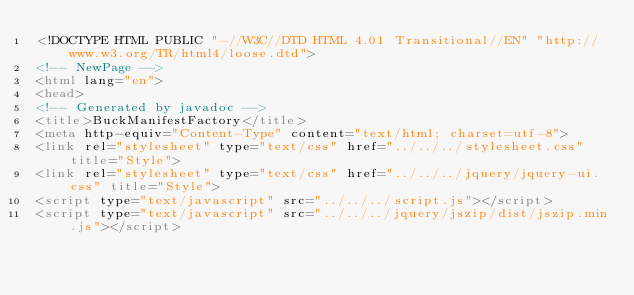Convert code to text. <code><loc_0><loc_0><loc_500><loc_500><_HTML_><!DOCTYPE HTML PUBLIC "-//W3C//DTD HTML 4.01 Transitional//EN" "http://www.w3.org/TR/html4/loose.dtd">
<!-- NewPage -->
<html lang="en">
<head>
<!-- Generated by javadoc -->
<title>BuckManifestFactory</title>
<meta http-equiv="Content-Type" content="text/html; charset=utf-8">
<link rel="stylesheet" type="text/css" href="../../../stylesheet.css" title="Style">
<link rel="stylesheet" type="text/css" href="../../../jquery/jquery-ui.css" title="Style">
<script type="text/javascript" src="../../../script.js"></script>
<script type="text/javascript" src="../../../jquery/jszip/dist/jszip.min.js"></script></code> 